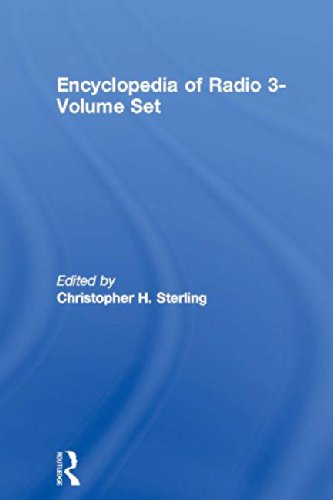Is this book related to Humor & Entertainment? The book is not related to Humor & Entertainment; it is an academic and reference work that focuses extensively on radio technology, history, and impact, aiming to educate and inform. 